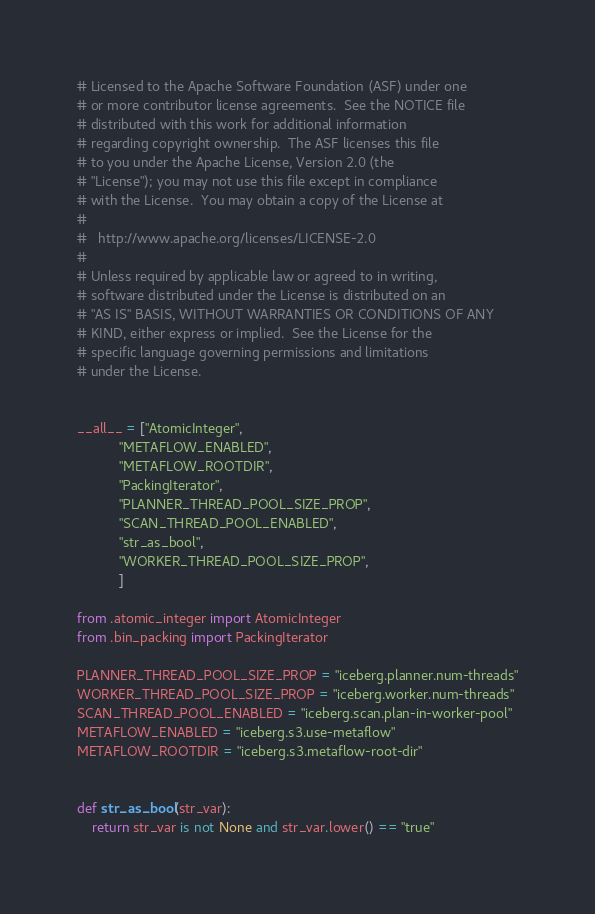<code> <loc_0><loc_0><loc_500><loc_500><_Python_># Licensed to the Apache Software Foundation (ASF) under one
# or more contributor license agreements.  See the NOTICE file
# distributed with this work for additional information
# regarding copyright ownership.  The ASF licenses this file
# to you under the Apache License, Version 2.0 (the
# "License"); you may not use this file except in compliance
# with the License.  You may obtain a copy of the License at
#
#   http://www.apache.org/licenses/LICENSE-2.0
#
# Unless required by applicable law or agreed to in writing,
# software distributed under the License is distributed on an
# "AS IS" BASIS, WITHOUT WARRANTIES OR CONDITIONS OF ANY
# KIND, either express or implied.  See the License for the
# specific language governing permissions and limitations
# under the License.


__all__ = ["AtomicInteger",
           "METAFLOW_ENABLED",
           "METAFLOW_ROOTDIR",
           "PackingIterator",
           "PLANNER_THREAD_POOL_SIZE_PROP",
           "SCAN_THREAD_POOL_ENABLED",
           "str_as_bool",
           "WORKER_THREAD_POOL_SIZE_PROP",
           ]

from .atomic_integer import AtomicInteger
from .bin_packing import PackingIterator

PLANNER_THREAD_POOL_SIZE_PROP = "iceberg.planner.num-threads"
WORKER_THREAD_POOL_SIZE_PROP = "iceberg.worker.num-threads"
SCAN_THREAD_POOL_ENABLED = "iceberg.scan.plan-in-worker-pool"
METAFLOW_ENABLED = "iceberg.s3.use-metaflow"
METAFLOW_ROOTDIR = "iceberg.s3.metaflow-root-dir"


def str_as_bool(str_var):
    return str_var is not None and str_var.lower() == "true"
</code> 